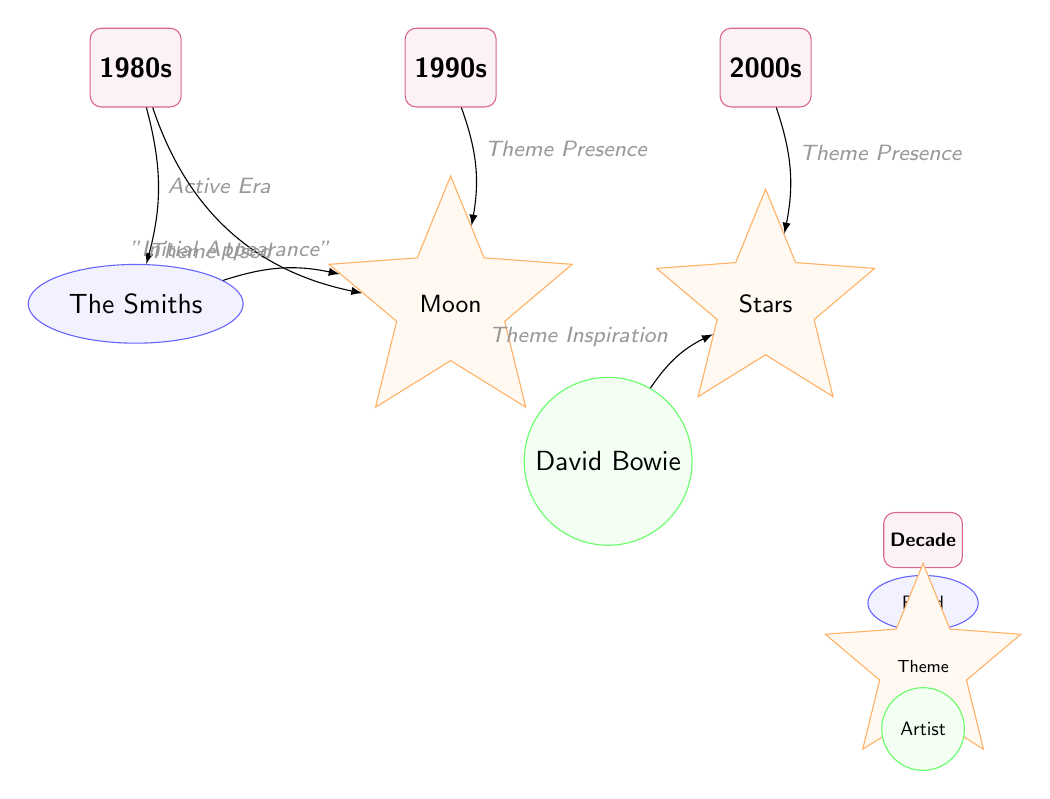What decade is associated with The Smiths? The diagram identifies The Smiths beneath the 1980s node, which indicates their active era. Therefore, The Smiths are associated with the 1980s.
Answer: 1980s How many themes are present in the 1990s? The 1990s node connects to one theme node, labeled "Moon." Therefore, there is one theme present in the 1990s.
Answer: 1 Which artist is linked to the theme "Stars"? The diagram shows a direct edge from the artist node for David Bowie to the theme node for "Stars." Thus, David Bowie is linked to the theme "Stars."
Answer: David Bowie What is the relationship between The Smiths and the "Moon" theme? The diagram indicates a flow from The Smiths node to the "Moon" theme node labeled "Theme Used," indicating that The Smiths utilized the "Moon" theme.
Answer: Theme Used What is the initial appearance theme in the 1980s? The diagram connects the 1980s node to the "Moon" theme node with a labeled edge "Initial Appearance," indicating that "Moon" was the first theme that appeared in that decade.
Answer: Moon Which decade shows a theme presence for the "Stars"? The diagram links the "Stars" theme to the 2000s node, and the edge labeled "Theme Presence" indicates that this theme is present in the 2000s.
Answer: 2000s How many total edges are there in the diagram? By counting the edges connecting the nodes, we find a total of six edges in the diagram that show relationships between the decades, bands, themes, and artists.
Answer: 6 Which decade first shows a theme presence? The diagram illustrates that the 1980s node is associated with the "Moon" theme through an edge labeled "Initial Appearance," defining the 1980s as the first decade showing a theme presence.
Answer: 1980s What does the edge labeled "Active Era" signify? The "Active Era" edge connects the 1980s node to The Smiths node, indicating that this represents the period when The Smiths were active.
Answer: Active Era 